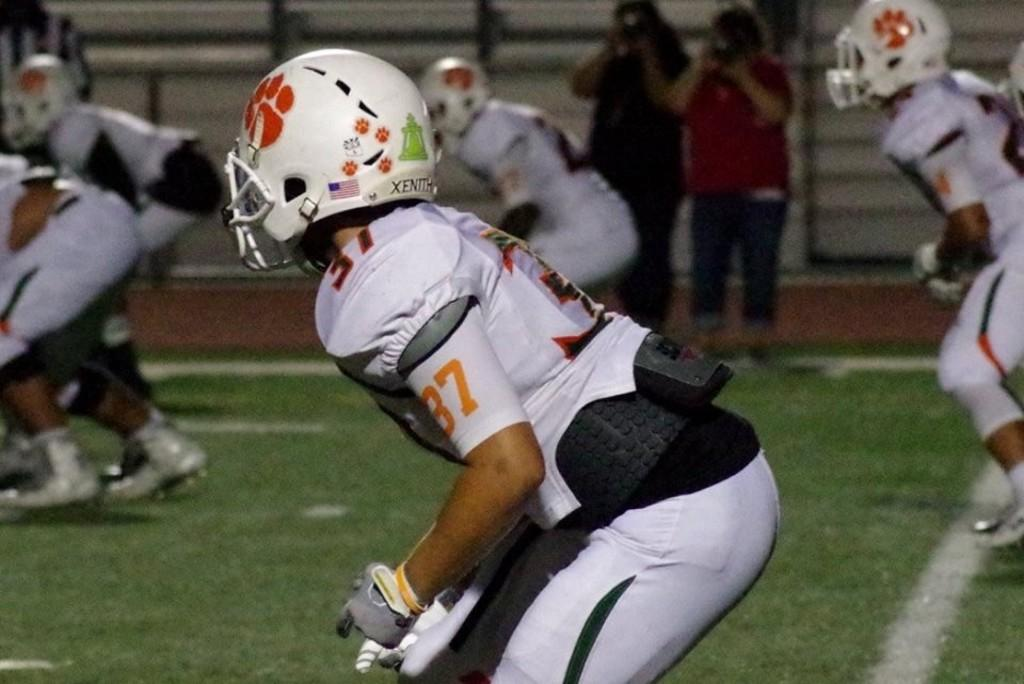What can be seen in the image? There is a group of people in the image. What are the people wearing? The people are wearing helmets. Are there any other people visible in the image? Yes, there are two persons in the background of the image. What are the two persons in the background doing? The two persons in the background are holding objects. What type of potato can be seen in the image? There is no potato present in the image. What kind of wood is being used by the two persons in the background? There is no wood visible in the image; the two persons in the background are holding objects, but their contents are not specified. 